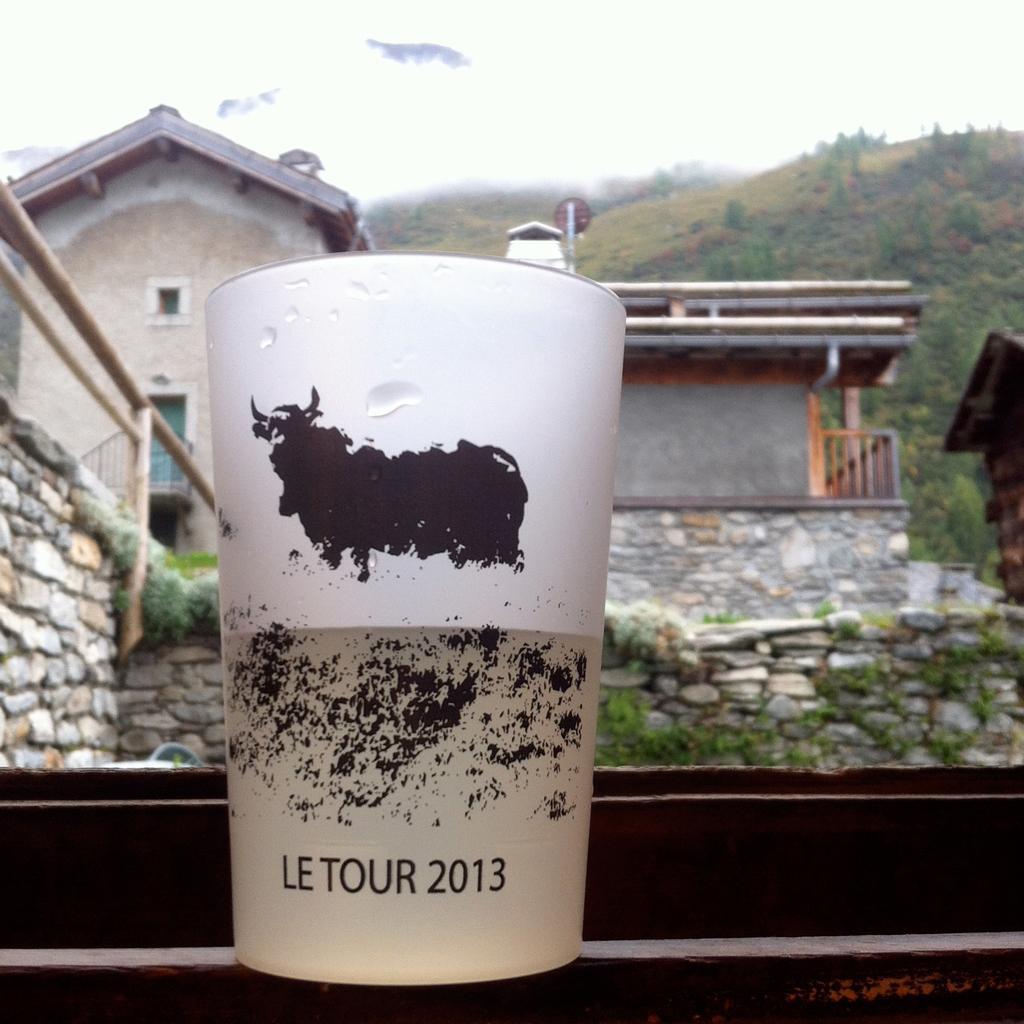Describe this image in one or two sentences. In this image there is a glass kept near the window. There is some text on the glass. Behind the glass there is a wall having a fence. There are plants on the wall. There are houses. Background there are hills. Top of the image there is sky. 